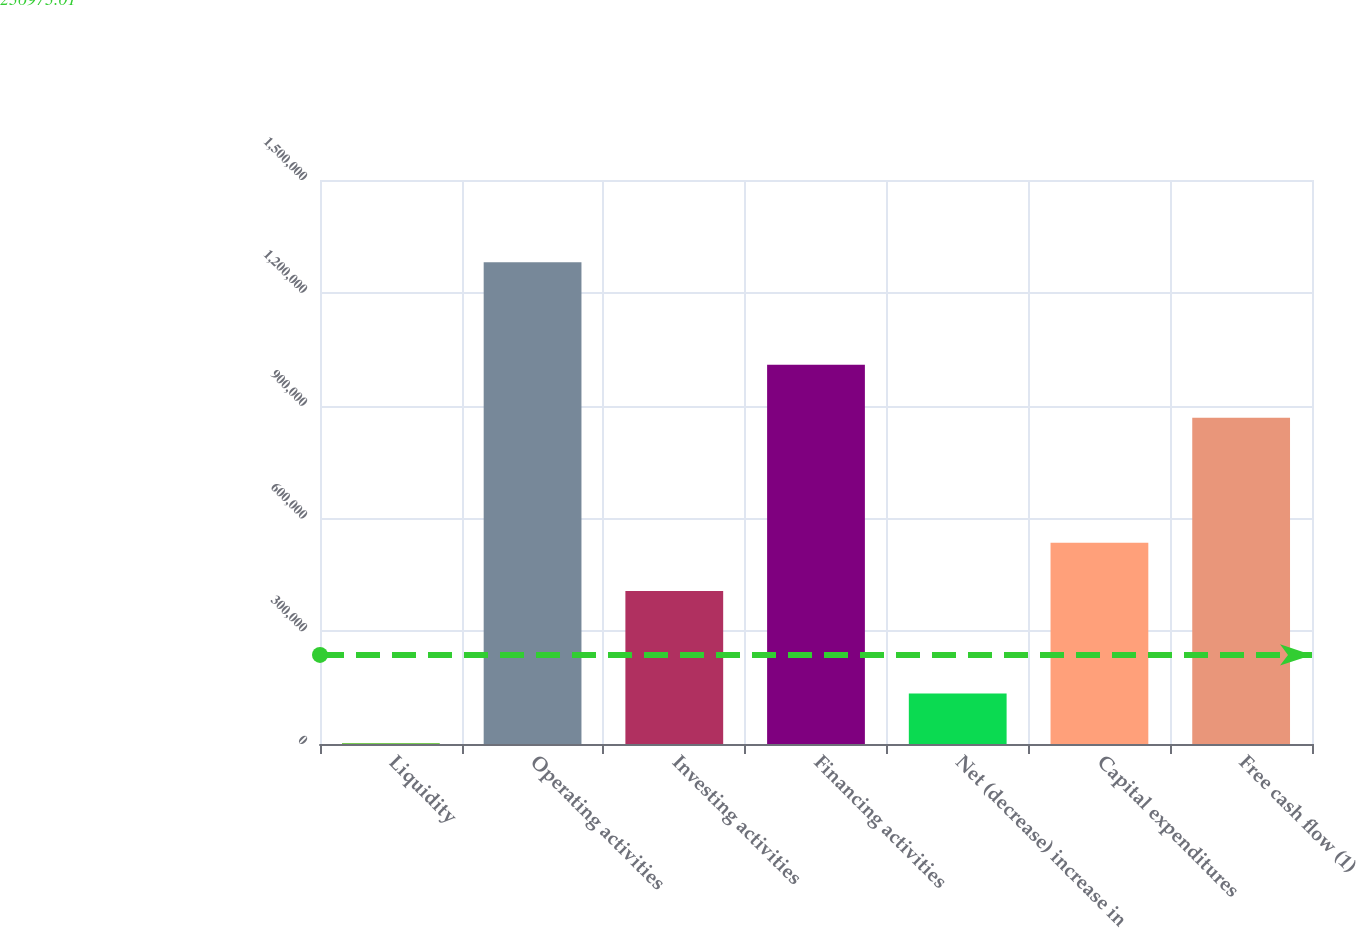Convert chart to OTSL. <chart><loc_0><loc_0><loc_500><loc_500><bar_chart><fcel>Liquidity<fcel>Operating activities<fcel>Investing activities<fcel>Financing activities<fcel>Net (decrease) increase in<fcel>Capital expenditures<fcel>Free cash flow (1)<nl><fcel>2015<fcel>1.28148e+06<fcel>407188<fcel>1.00855e+06<fcel>134259<fcel>535134<fcel>867456<nl></chart> 